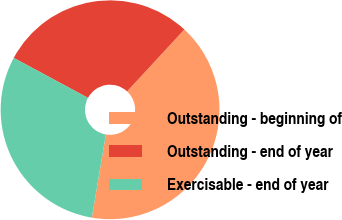Convert chart to OTSL. <chart><loc_0><loc_0><loc_500><loc_500><pie_chart><fcel>Outstanding - beginning of<fcel>Outstanding - end of year<fcel>Exercisable - end of year<nl><fcel>40.78%<fcel>29.02%<fcel>30.2%<nl></chart> 